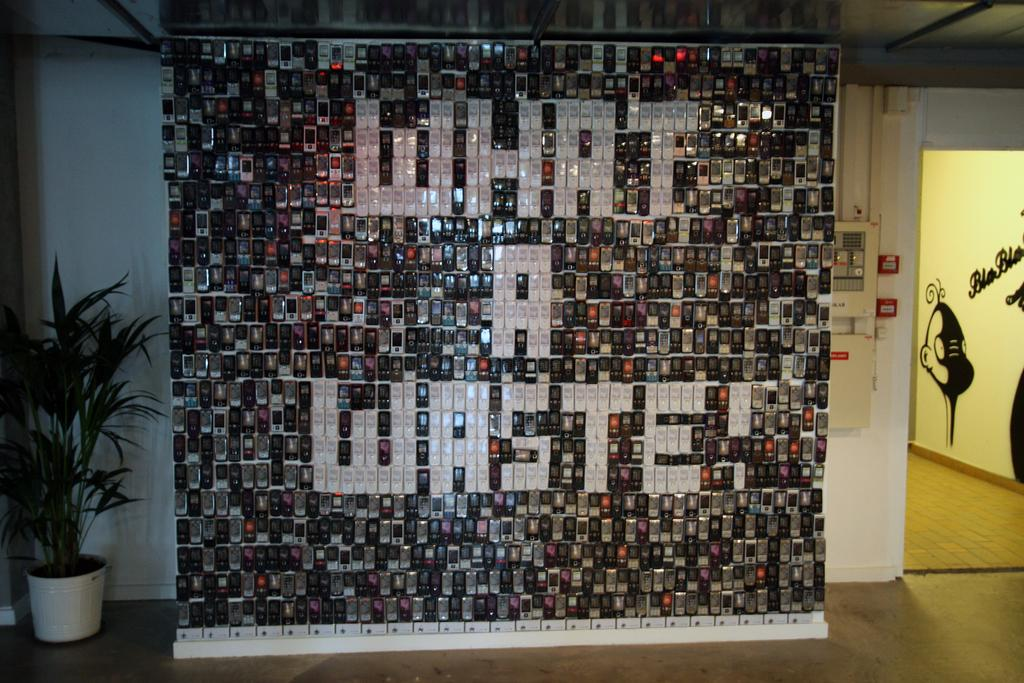Provide a one-sentence caption for the provided image. a wall of many cell phones with the message What a waste in them. 